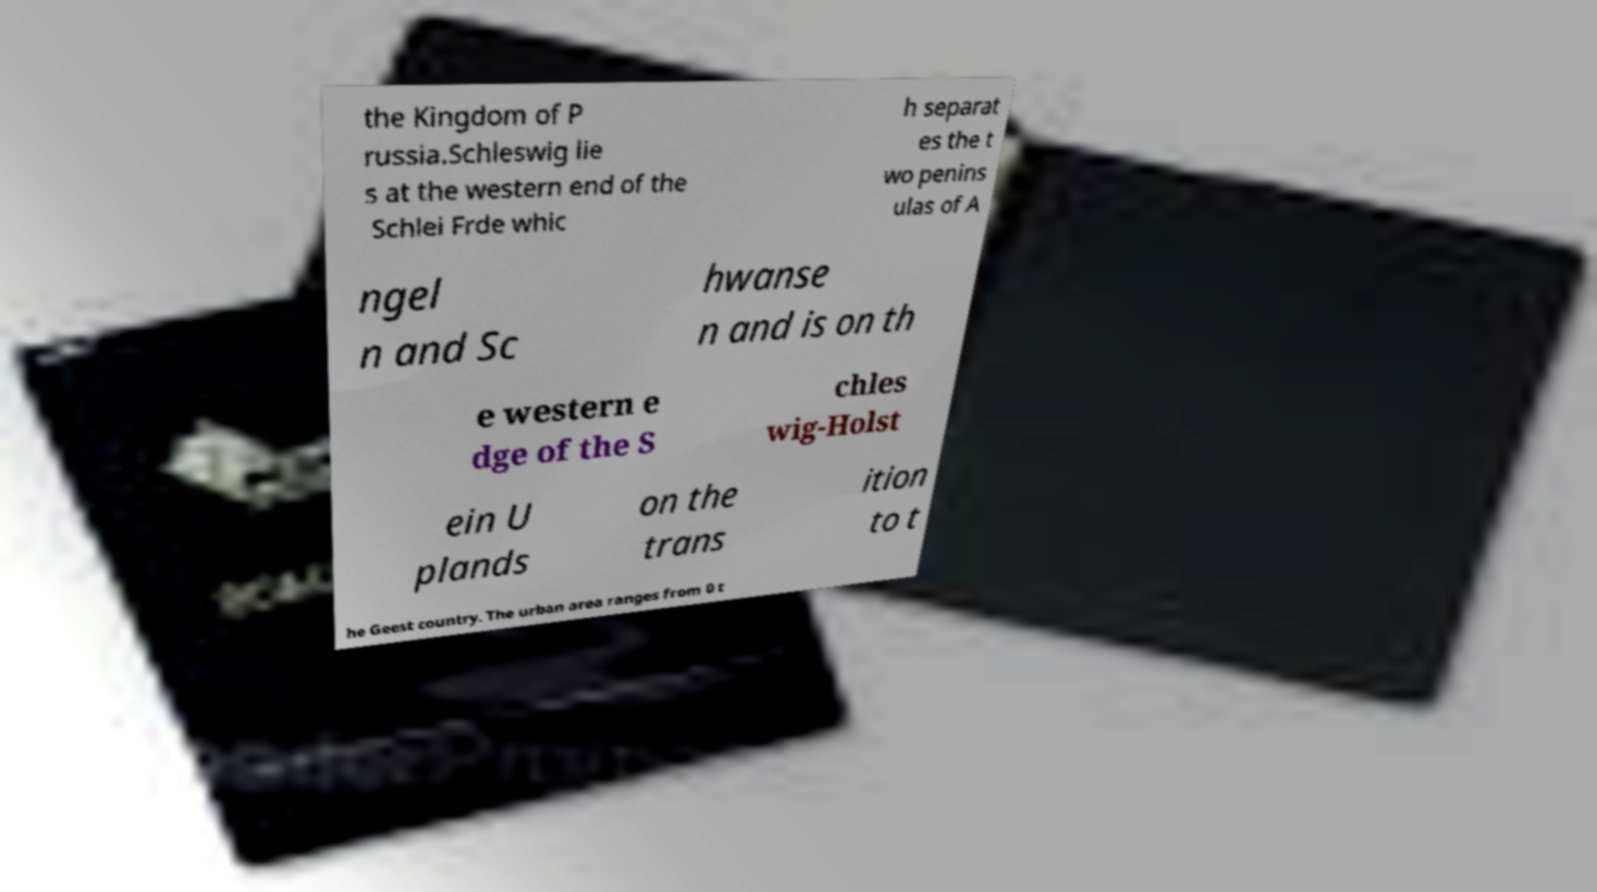Can you accurately transcribe the text from the provided image for me? the Kingdom of P russia.Schleswig lie s at the western end of the Schlei Frde whic h separat es the t wo penins ulas of A ngel n and Sc hwanse n and is on th e western e dge of the S chles wig-Holst ein U plands on the trans ition to t he Geest country. The urban area ranges from 0 t 